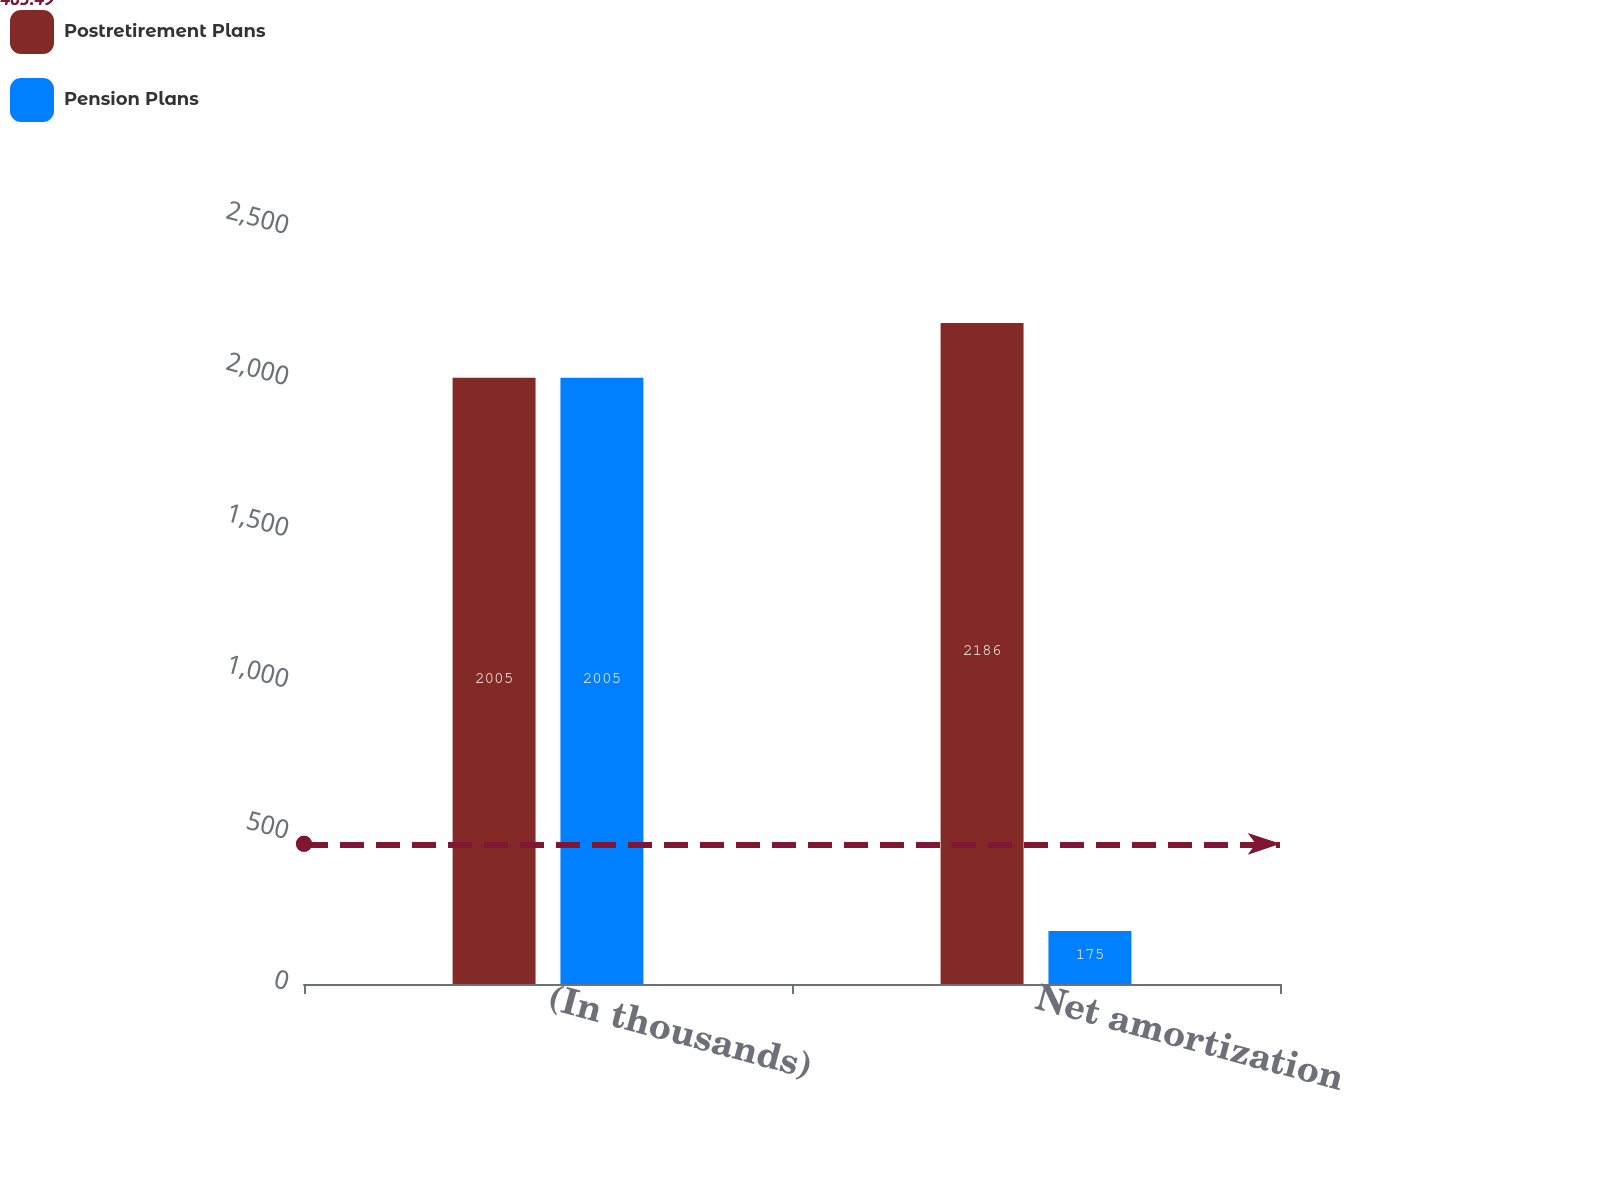Convert chart to OTSL. <chart><loc_0><loc_0><loc_500><loc_500><stacked_bar_chart><ecel><fcel>(In thousands)<fcel>Net amortization<nl><fcel>Postretirement Plans<fcel>2005<fcel>2186<nl><fcel>Pension Plans<fcel>2005<fcel>175<nl></chart> 